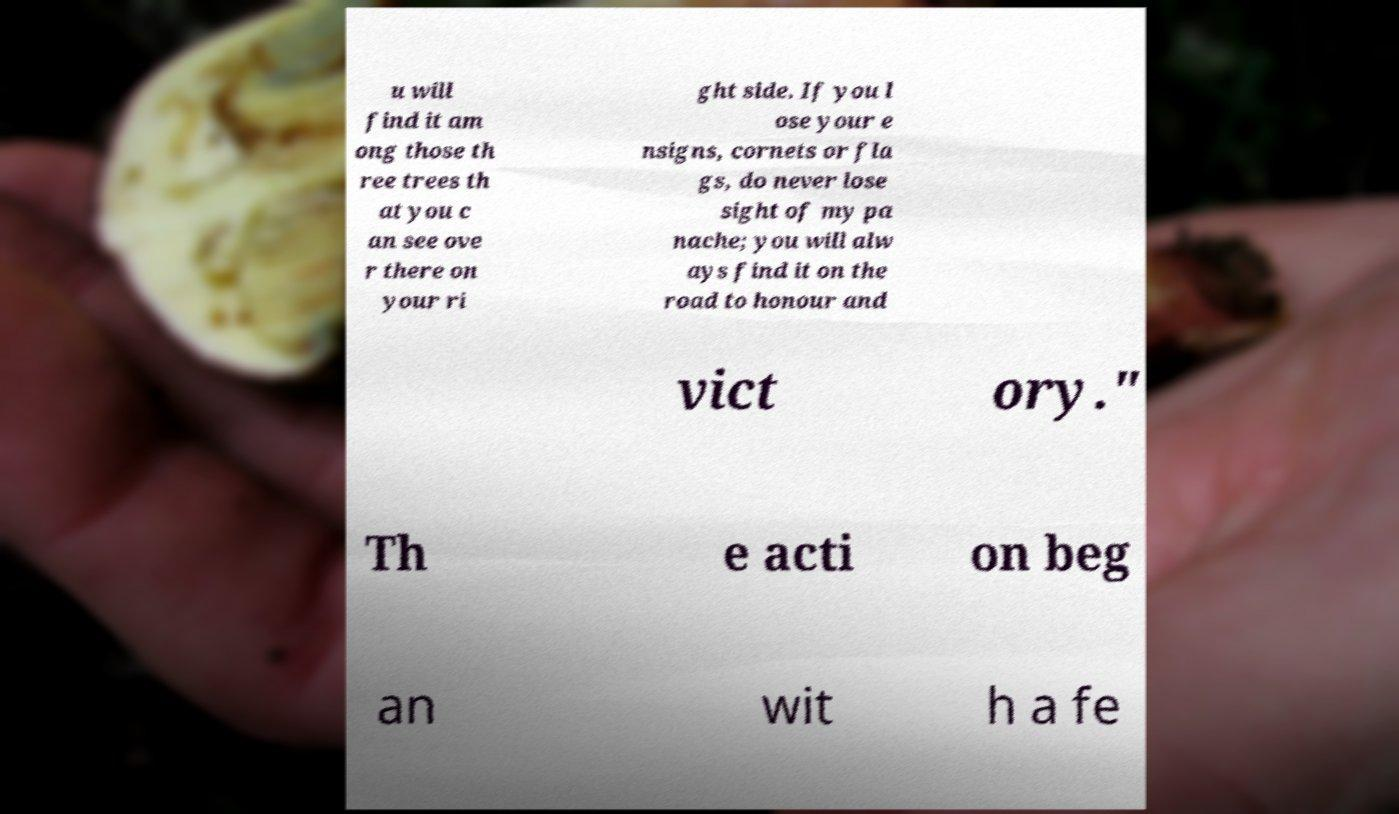What messages or text are displayed in this image? I need them in a readable, typed format. u will find it am ong those th ree trees th at you c an see ove r there on your ri ght side. If you l ose your e nsigns, cornets or fla gs, do never lose sight of my pa nache; you will alw ays find it on the road to honour and vict ory." Th e acti on beg an wit h a fe 